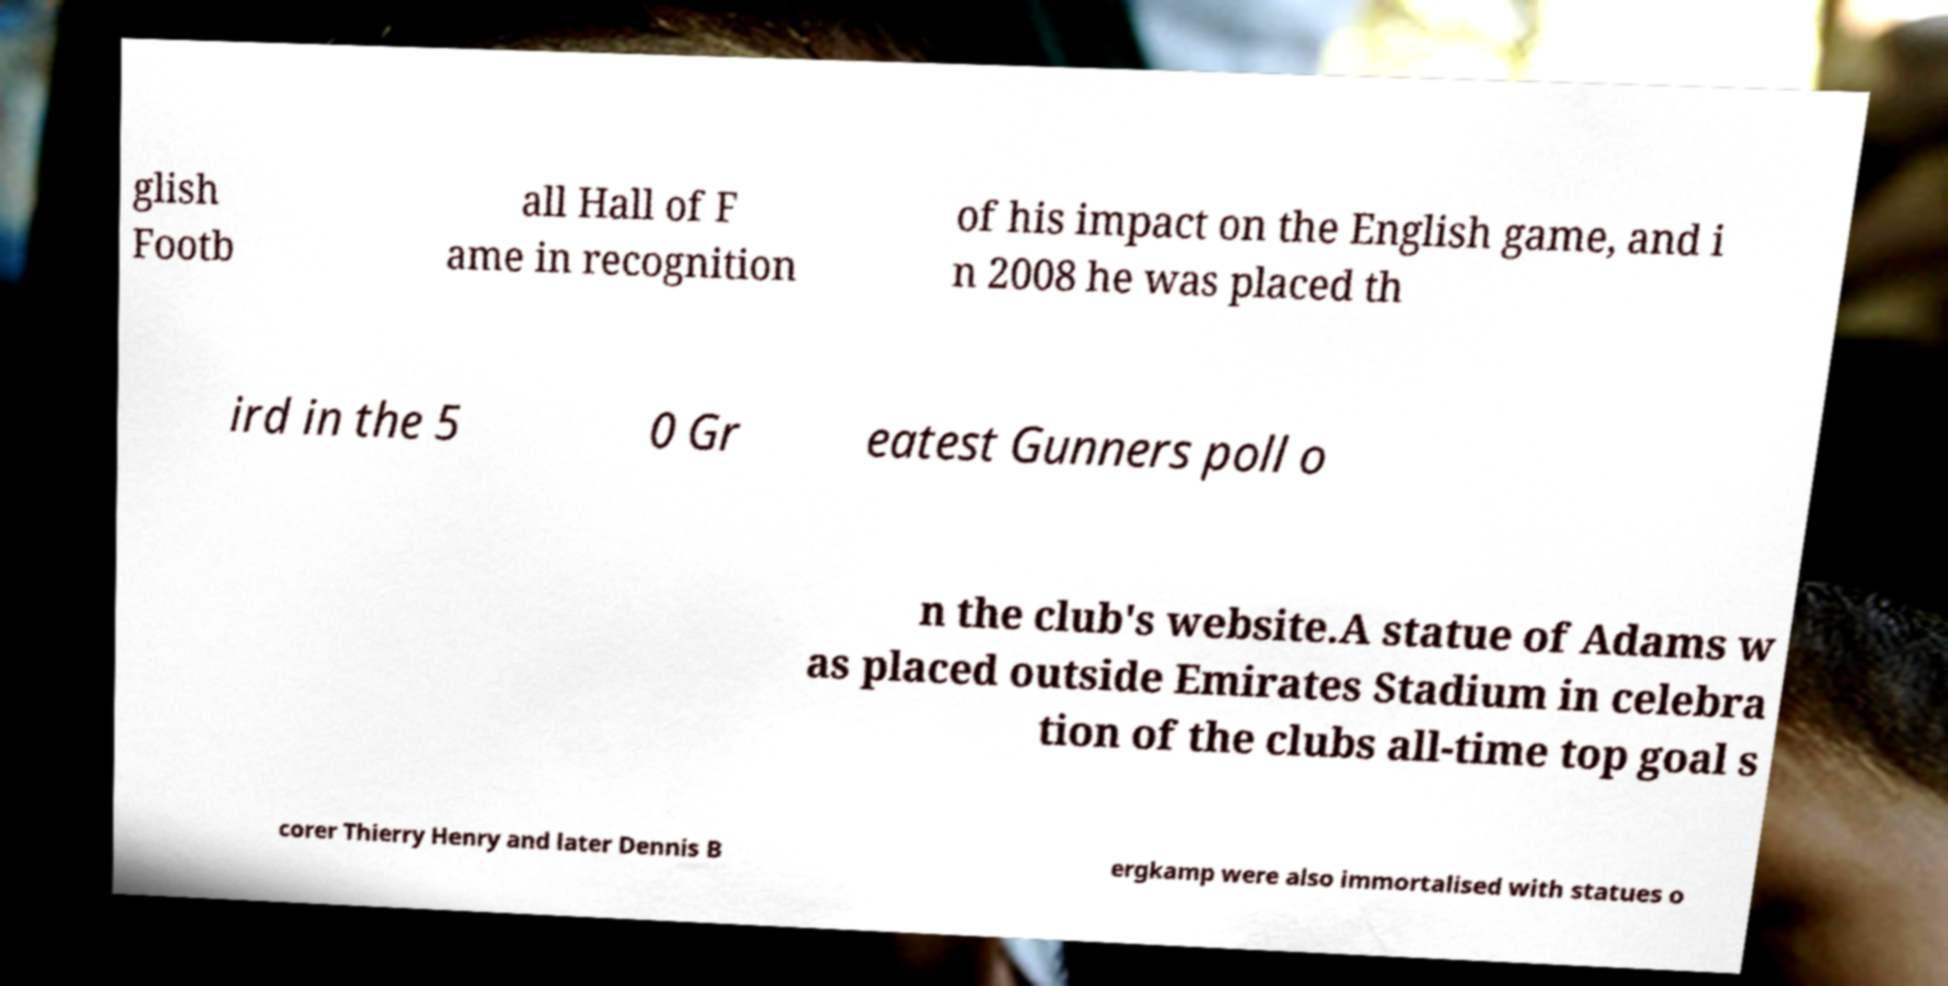Could you assist in decoding the text presented in this image and type it out clearly? glish Footb all Hall of F ame in recognition of his impact on the English game, and i n 2008 he was placed th ird in the 5 0 Gr eatest Gunners poll o n the club's website.A statue of Adams w as placed outside Emirates Stadium in celebra tion of the clubs all-time top goal s corer Thierry Henry and later Dennis B ergkamp were also immortalised with statues o 